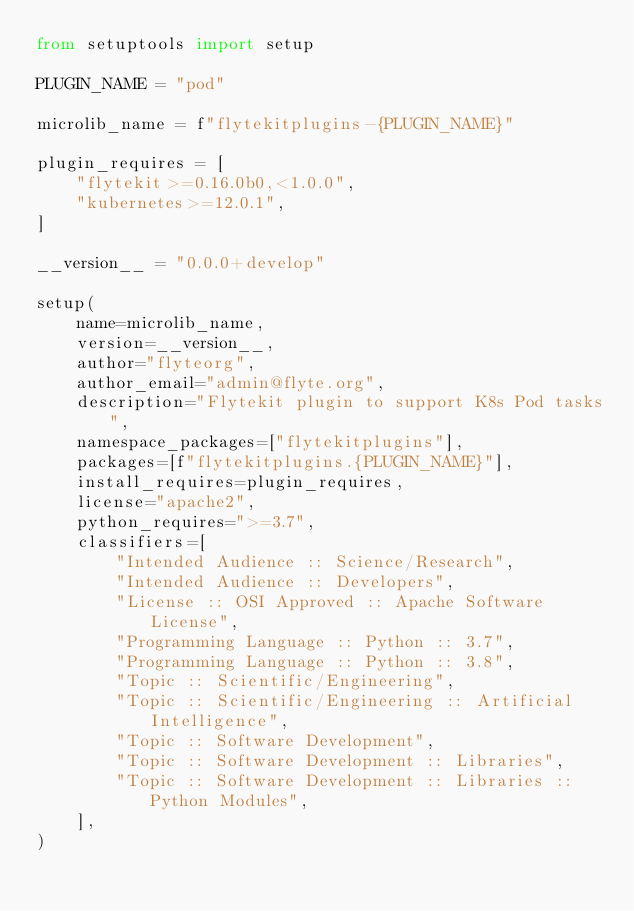<code> <loc_0><loc_0><loc_500><loc_500><_Python_>from setuptools import setup

PLUGIN_NAME = "pod"

microlib_name = f"flytekitplugins-{PLUGIN_NAME}"

plugin_requires = [
    "flytekit>=0.16.0b0,<1.0.0",
    "kubernetes>=12.0.1",
]

__version__ = "0.0.0+develop"

setup(
    name=microlib_name,
    version=__version__,
    author="flyteorg",
    author_email="admin@flyte.org",
    description="Flytekit plugin to support K8s Pod tasks",
    namespace_packages=["flytekitplugins"],
    packages=[f"flytekitplugins.{PLUGIN_NAME}"],
    install_requires=plugin_requires,
    license="apache2",
    python_requires=">=3.7",
    classifiers=[
        "Intended Audience :: Science/Research",
        "Intended Audience :: Developers",
        "License :: OSI Approved :: Apache Software License",
        "Programming Language :: Python :: 3.7",
        "Programming Language :: Python :: 3.8",
        "Topic :: Scientific/Engineering",
        "Topic :: Scientific/Engineering :: Artificial Intelligence",
        "Topic :: Software Development",
        "Topic :: Software Development :: Libraries",
        "Topic :: Software Development :: Libraries :: Python Modules",
    ],
)
</code> 